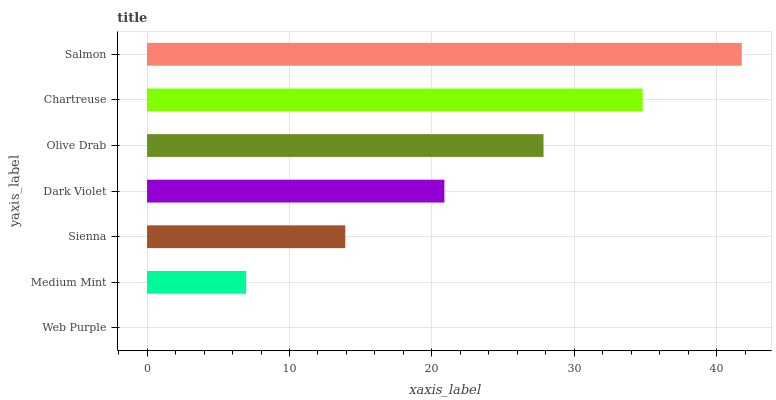Is Web Purple the minimum?
Answer yes or no. Yes. Is Salmon the maximum?
Answer yes or no. Yes. Is Medium Mint the minimum?
Answer yes or no. No. Is Medium Mint the maximum?
Answer yes or no. No. Is Medium Mint greater than Web Purple?
Answer yes or no. Yes. Is Web Purple less than Medium Mint?
Answer yes or no. Yes. Is Web Purple greater than Medium Mint?
Answer yes or no. No. Is Medium Mint less than Web Purple?
Answer yes or no. No. Is Dark Violet the high median?
Answer yes or no. Yes. Is Dark Violet the low median?
Answer yes or no. Yes. Is Olive Drab the high median?
Answer yes or no. No. Is Sienna the low median?
Answer yes or no. No. 